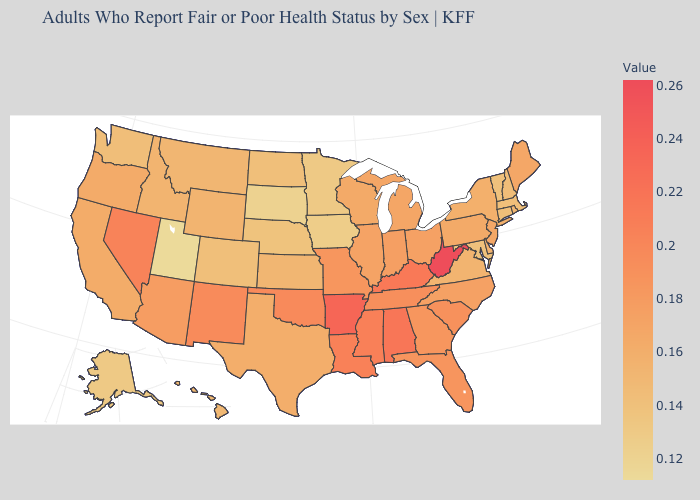Does Utah have the lowest value in the USA?
Write a very short answer. Yes. Among the states that border Tennessee , does Georgia have the highest value?
Answer briefly. No. Which states have the lowest value in the USA?
Quick response, please. Utah. Which states have the highest value in the USA?
Write a very short answer. West Virginia. Is the legend a continuous bar?
Give a very brief answer. Yes. 